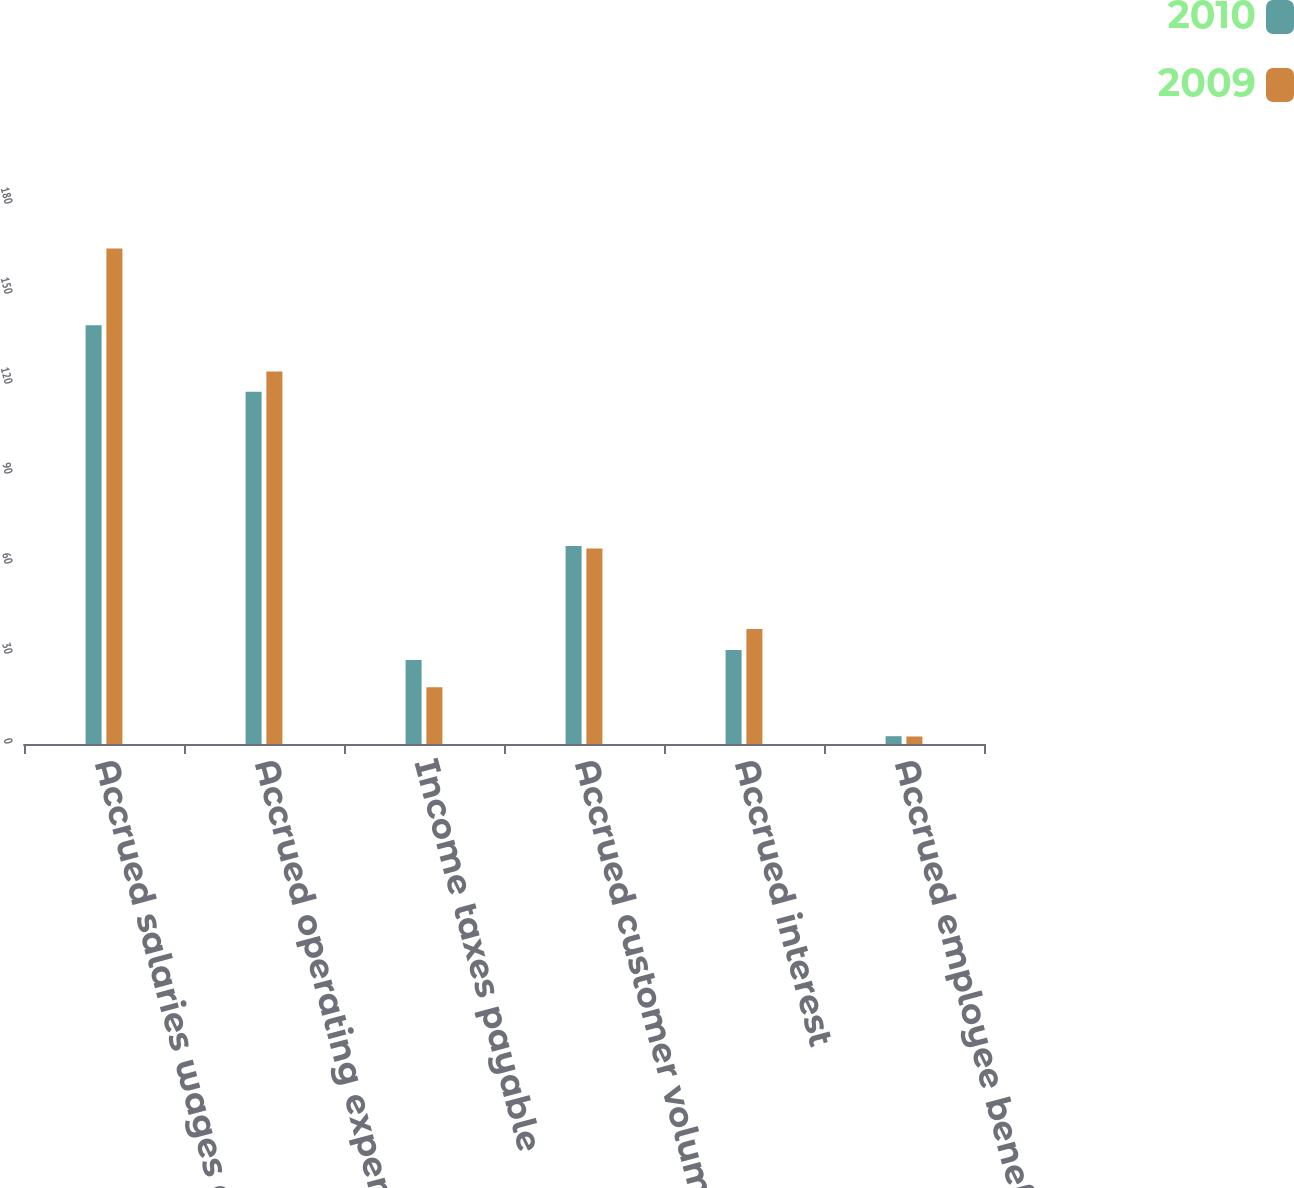Convert chart. <chart><loc_0><loc_0><loc_500><loc_500><stacked_bar_chart><ecel><fcel>Accrued salaries wages and<fcel>Accrued operating expenses<fcel>Income taxes payable<fcel>Accrued customer volume<fcel>Accrued interest<fcel>Accrued employee benefit<nl><fcel>2010<fcel>139.6<fcel>117.4<fcel>28<fcel>66<fcel>31.3<fcel>2.6<nl><fcel>2009<fcel>165.2<fcel>124.2<fcel>18.9<fcel>65.2<fcel>38.3<fcel>2.5<nl></chart> 